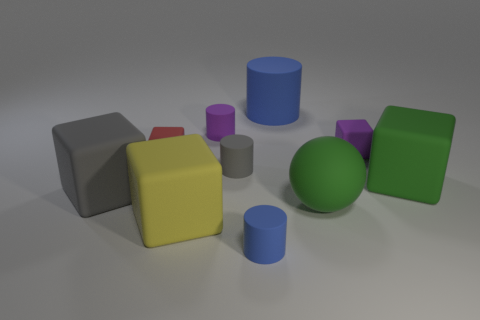Subtract all red rubber blocks. How many blocks are left? 4 Subtract all yellow blocks. How many blocks are left? 4 Subtract all cylinders. How many objects are left? 6 Subtract 1 cylinders. How many cylinders are left? 3 Subtract all yellow spheres. Subtract all green blocks. How many spheres are left? 1 Subtract all brown cubes. How many blue cylinders are left? 2 Subtract all gray matte cylinders. Subtract all matte spheres. How many objects are left? 8 Add 4 gray matte cylinders. How many gray matte cylinders are left? 5 Add 6 tiny blue rubber objects. How many tiny blue rubber objects exist? 7 Subtract 1 blue cylinders. How many objects are left? 9 